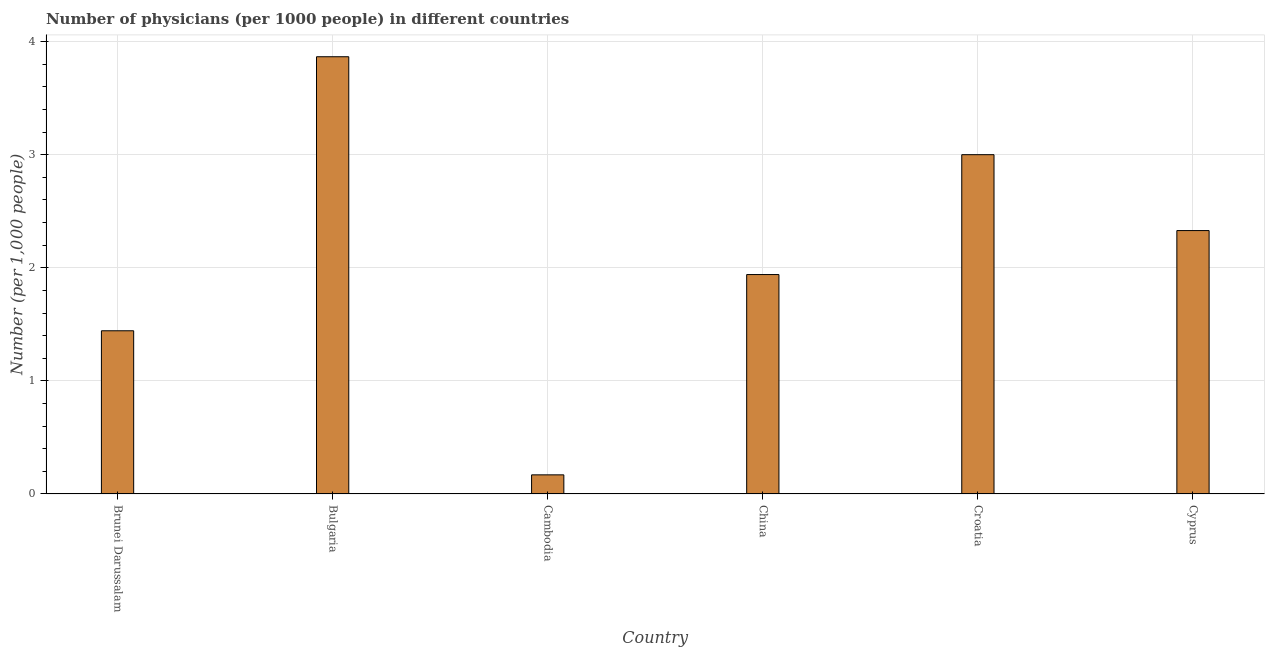Does the graph contain any zero values?
Your answer should be compact. No. What is the title of the graph?
Provide a succinct answer. Number of physicians (per 1000 people) in different countries. What is the label or title of the Y-axis?
Your answer should be very brief. Number (per 1,0 people). What is the number of physicians in Cambodia?
Provide a short and direct response. 0.17. Across all countries, what is the maximum number of physicians?
Make the answer very short. 3.87. Across all countries, what is the minimum number of physicians?
Provide a succinct answer. 0.17. In which country was the number of physicians minimum?
Your response must be concise. Cambodia. What is the sum of the number of physicians?
Provide a succinct answer. 12.75. What is the difference between the number of physicians in Brunei Darussalam and Cyprus?
Your response must be concise. -0.89. What is the average number of physicians per country?
Ensure brevity in your answer.  2.12. What is the median number of physicians?
Your answer should be compact. 2.13. What is the ratio of the number of physicians in Bulgaria to that in Cyprus?
Offer a terse response. 1.66. Is the difference between the number of physicians in China and Croatia greater than the difference between any two countries?
Keep it short and to the point. No. What is the difference between the highest and the second highest number of physicians?
Make the answer very short. 0.87. How many bars are there?
Provide a succinct answer. 6. Are all the bars in the graph horizontal?
Ensure brevity in your answer.  No. What is the Number (per 1,000 people) of Brunei Darussalam?
Give a very brief answer. 1.44. What is the Number (per 1,000 people) in Bulgaria?
Ensure brevity in your answer.  3.87. What is the Number (per 1,000 people) in Cambodia?
Your answer should be very brief. 0.17. What is the Number (per 1,000 people) of China?
Your answer should be compact. 1.94. What is the Number (per 1,000 people) in Cyprus?
Provide a succinct answer. 2.33. What is the difference between the Number (per 1,000 people) in Brunei Darussalam and Bulgaria?
Provide a short and direct response. -2.42. What is the difference between the Number (per 1,000 people) in Brunei Darussalam and Cambodia?
Offer a very short reply. 1.27. What is the difference between the Number (per 1,000 people) in Brunei Darussalam and China?
Provide a short and direct response. -0.5. What is the difference between the Number (per 1,000 people) in Brunei Darussalam and Croatia?
Your answer should be very brief. -1.56. What is the difference between the Number (per 1,000 people) in Brunei Darussalam and Cyprus?
Provide a succinct answer. -0.89. What is the difference between the Number (per 1,000 people) in Bulgaria and Cambodia?
Your answer should be compact. 3.7. What is the difference between the Number (per 1,000 people) in Bulgaria and China?
Your answer should be compact. 1.93. What is the difference between the Number (per 1,000 people) in Bulgaria and Croatia?
Provide a succinct answer. 0.87. What is the difference between the Number (per 1,000 people) in Bulgaria and Cyprus?
Your answer should be compact. 1.54. What is the difference between the Number (per 1,000 people) in Cambodia and China?
Offer a terse response. -1.77. What is the difference between the Number (per 1,000 people) in Cambodia and Croatia?
Provide a succinct answer. -2.83. What is the difference between the Number (per 1,000 people) in Cambodia and Cyprus?
Offer a terse response. -2.16. What is the difference between the Number (per 1,000 people) in China and Croatia?
Provide a short and direct response. -1.06. What is the difference between the Number (per 1,000 people) in China and Cyprus?
Keep it short and to the point. -0.39. What is the difference between the Number (per 1,000 people) in Croatia and Cyprus?
Give a very brief answer. 0.67. What is the ratio of the Number (per 1,000 people) in Brunei Darussalam to that in Bulgaria?
Your answer should be compact. 0.37. What is the ratio of the Number (per 1,000 people) in Brunei Darussalam to that in Cambodia?
Offer a terse response. 8.54. What is the ratio of the Number (per 1,000 people) in Brunei Darussalam to that in China?
Provide a short and direct response. 0.74. What is the ratio of the Number (per 1,000 people) in Brunei Darussalam to that in Croatia?
Your answer should be compact. 0.48. What is the ratio of the Number (per 1,000 people) in Brunei Darussalam to that in Cyprus?
Keep it short and to the point. 0.62. What is the ratio of the Number (per 1,000 people) in Bulgaria to that in Cambodia?
Your answer should be compact. 22.88. What is the ratio of the Number (per 1,000 people) in Bulgaria to that in China?
Your response must be concise. 1.99. What is the ratio of the Number (per 1,000 people) in Bulgaria to that in Croatia?
Your answer should be compact. 1.29. What is the ratio of the Number (per 1,000 people) in Bulgaria to that in Cyprus?
Ensure brevity in your answer.  1.66. What is the ratio of the Number (per 1,000 people) in Cambodia to that in China?
Offer a very short reply. 0.09. What is the ratio of the Number (per 1,000 people) in Cambodia to that in Croatia?
Provide a succinct answer. 0.06. What is the ratio of the Number (per 1,000 people) in Cambodia to that in Cyprus?
Provide a short and direct response. 0.07. What is the ratio of the Number (per 1,000 people) in China to that in Croatia?
Offer a very short reply. 0.65. What is the ratio of the Number (per 1,000 people) in China to that in Cyprus?
Your answer should be very brief. 0.83. What is the ratio of the Number (per 1,000 people) in Croatia to that in Cyprus?
Give a very brief answer. 1.29. 